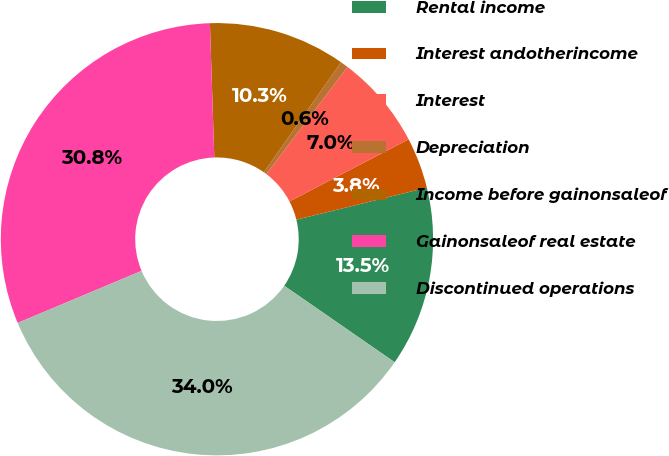Convert chart to OTSL. <chart><loc_0><loc_0><loc_500><loc_500><pie_chart><fcel>Rental income<fcel>Interest andotherincome<fcel>Interest<fcel>Depreciation<fcel>Income before gainonsaleof<fcel>Gainonsaleof real estate<fcel>Discontinued operations<nl><fcel>13.47%<fcel>3.81%<fcel>7.03%<fcel>0.59%<fcel>10.25%<fcel>30.81%<fcel>34.03%<nl></chart> 